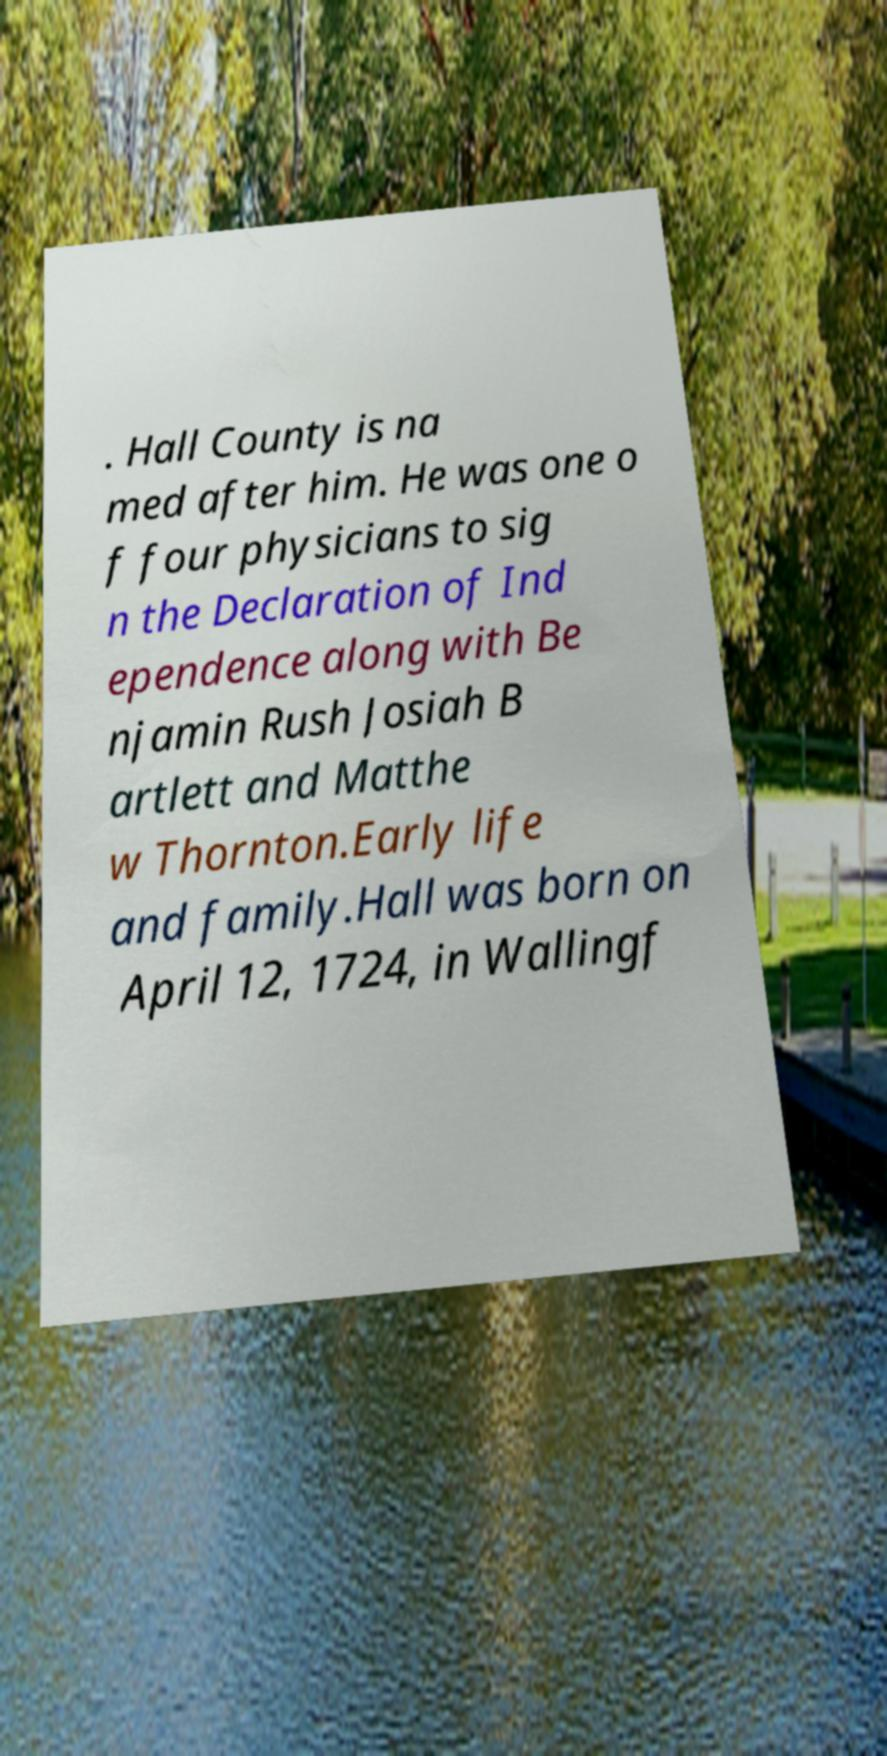Could you assist in decoding the text presented in this image and type it out clearly? . Hall County is na med after him. He was one o f four physicians to sig n the Declaration of Ind ependence along with Be njamin Rush Josiah B artlett and Matthe w Thornton.Early life and family.Hall was born on April 12, 1724, in Wallingf 